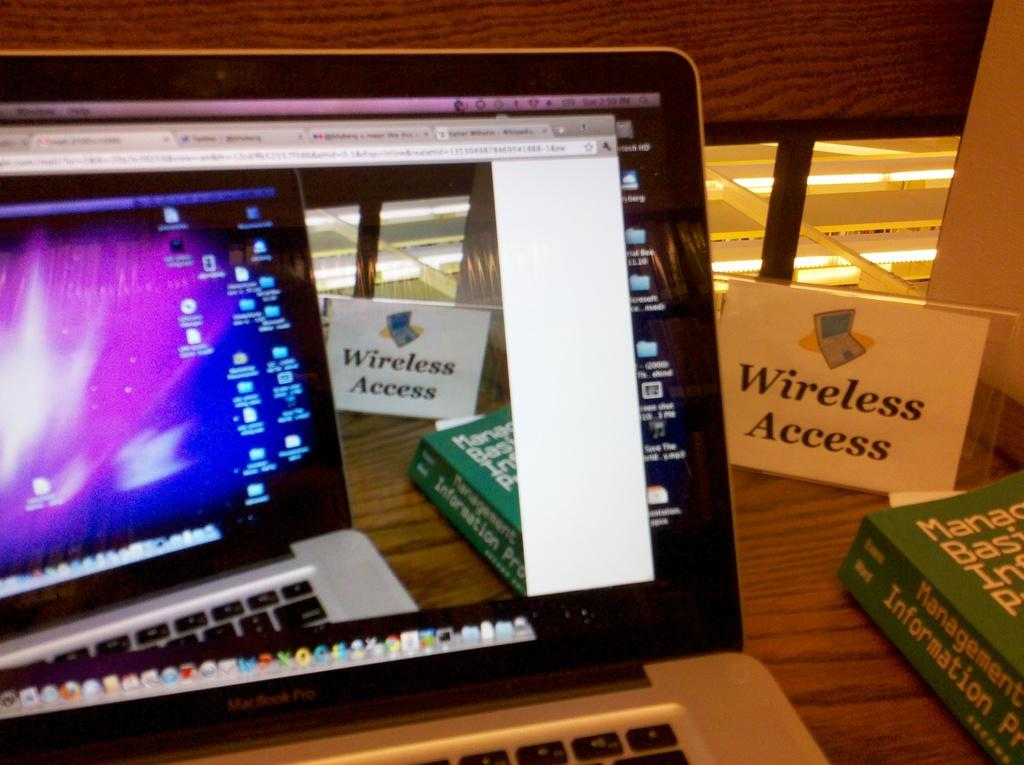<image>
Summarize the visual content of the image. an open lap top computer next to a Wireless Access sign 